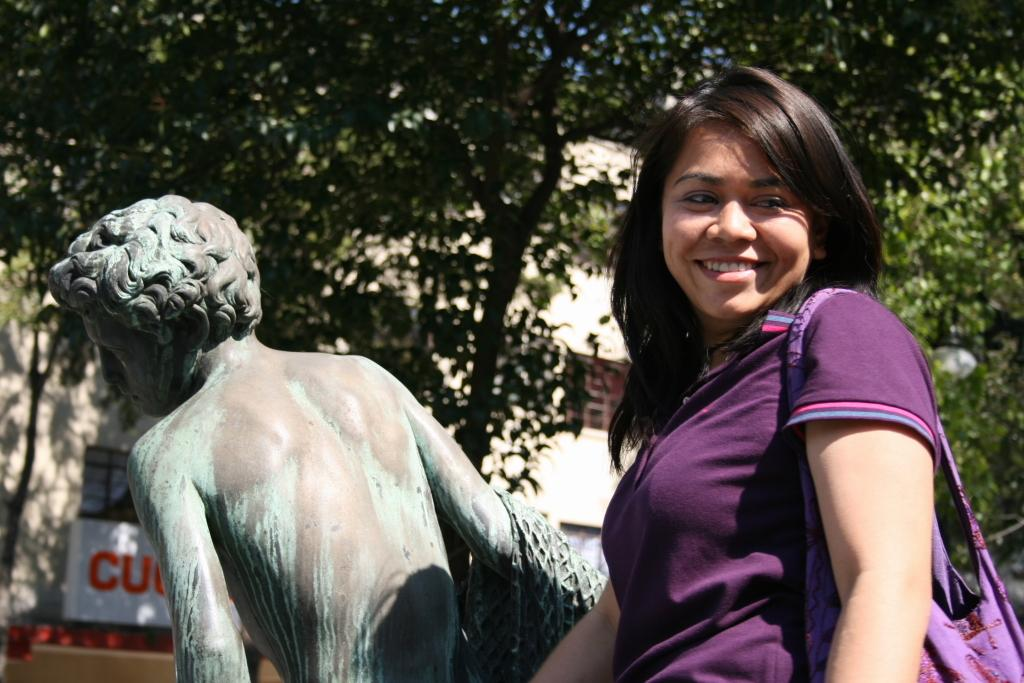Who is present in the image? There is a person in the image. What is the person's facial expression? The person is smiling. What color is the top the person is wearing? The person is wearing a purple top. What is the person carrying? The person is carrying a bag. What can be seen in the background of the image? There is a statue, trees, a building, and boards visible in the background. What type of cracker is the person eating in the image? There is no cracker present in the image, and the person is not eating anything. 